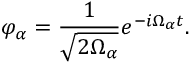Convert formula to latex. <formula><loc_0><loc_0><loc_500><loc_500>\varphi _ { \alpha } = \frac { 1 } { \sqrt { 2 \Omega _ { \alpha } } } e ^ { - i \Omega _ { \alpha } t } .</formula> 